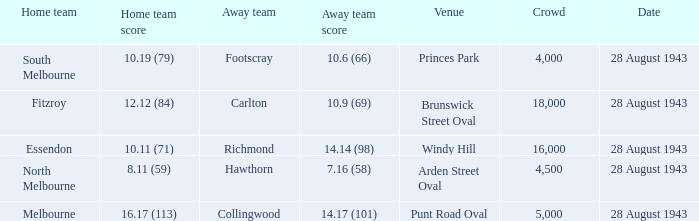What game showed a home team score of 8.11 (59)? 28 August 1943. 